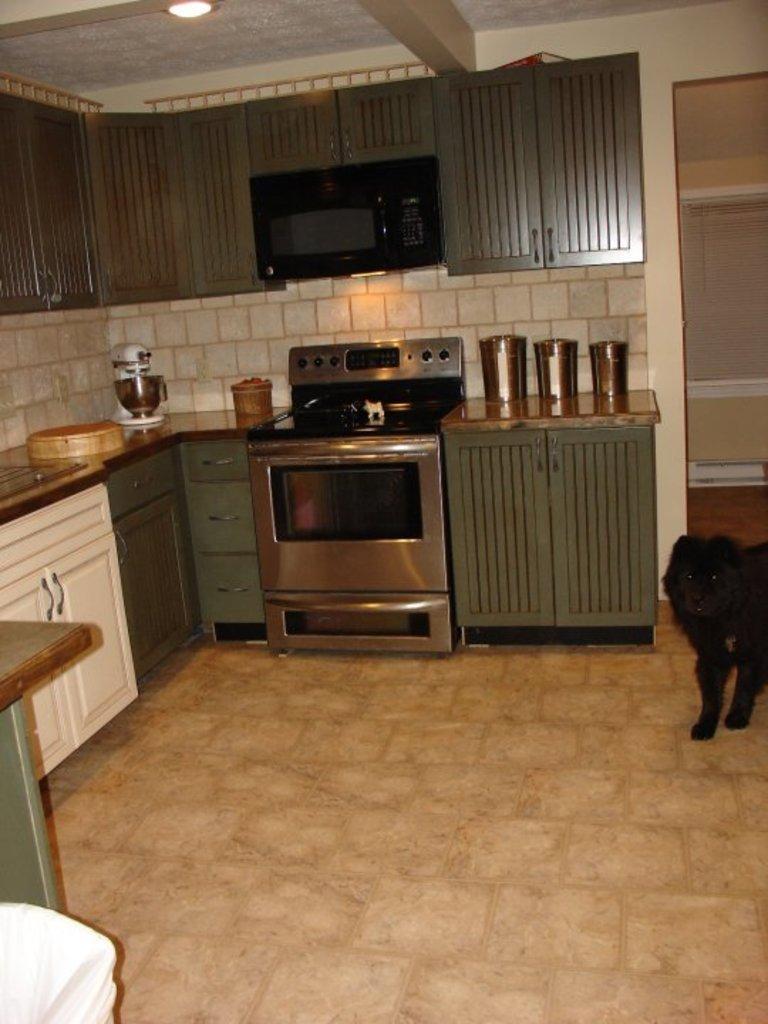In one or two sentences, can you explain what this image depicts? In the image we can see there is a kitchen and there is a oven, gas stove and there are three steel vessels which are kept on a table and over here we can see there is a black colour dog. 